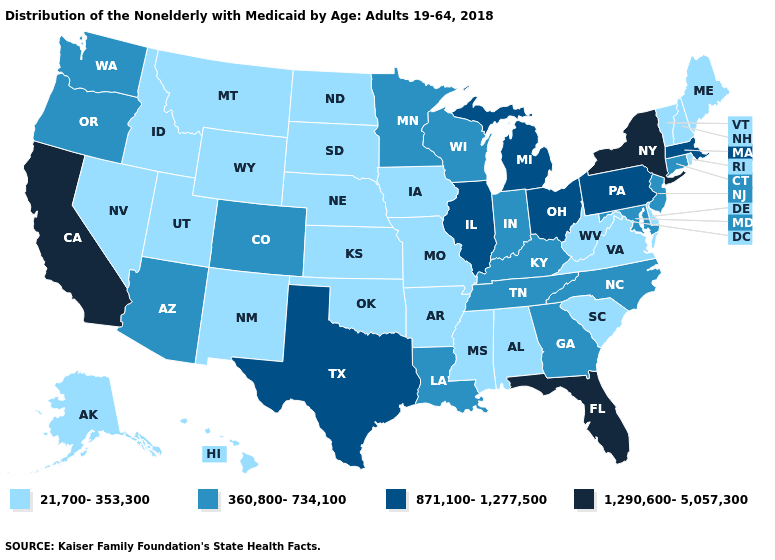Does Wisconsin have the highest value in the MidWest?
Give a very brief answer. No. Which states have the highest value in the USA?
Quick response, please. California, Florida, New York. Among the states that border Idaho , does Oregon have the highest value?
Write a very short answer. Yes. Among the states that border North Carolina , does Virginia have the highest value?
Quick response, please. No. What is the lowest value in states that border South Dakota?
Keep it brief. 21,700-353,300. Name the states that have a value in the range 1,290,600-5,057,300?
Short answer required. California, Florida, New York. How many symbols are there in the legend?
Give a very brief answer. 4. Which states have the highest value in the USA?
Give a very brief answer. California, Florida, New York. Which states have the highest value in the USA?
Answer briefly. California, Florida, New York. Does Colorado have the lowest value in the USA?
Concise answer only. No. Name the states that have a value in the range 871,100-1,277,500?
Be succinct. Illinois, Massachusetts, Michigan, Ohio, Pennsylvania, Texas. What is the value of Nebraska?
Keep it brief. 21,700-353,300. Among the states that border Wisconsin , does Iowa have the highest value?
Write a very short answer. No. What is the value of Florida?
Write a very short answer. 1,290,600-5,057,300. What is the value of Nebraska?
Answer briefly. 21,700-353,300. 